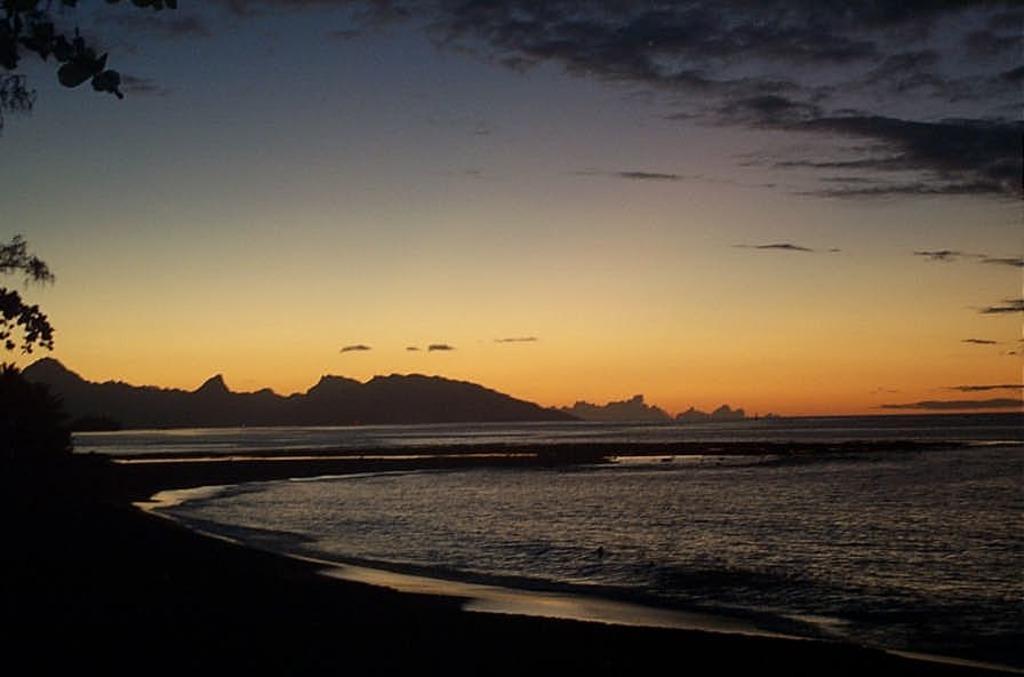Describe this image in one or two sentences. In this image I can see water, trees, mountains and the sky. This image is taken may be in the evening. 